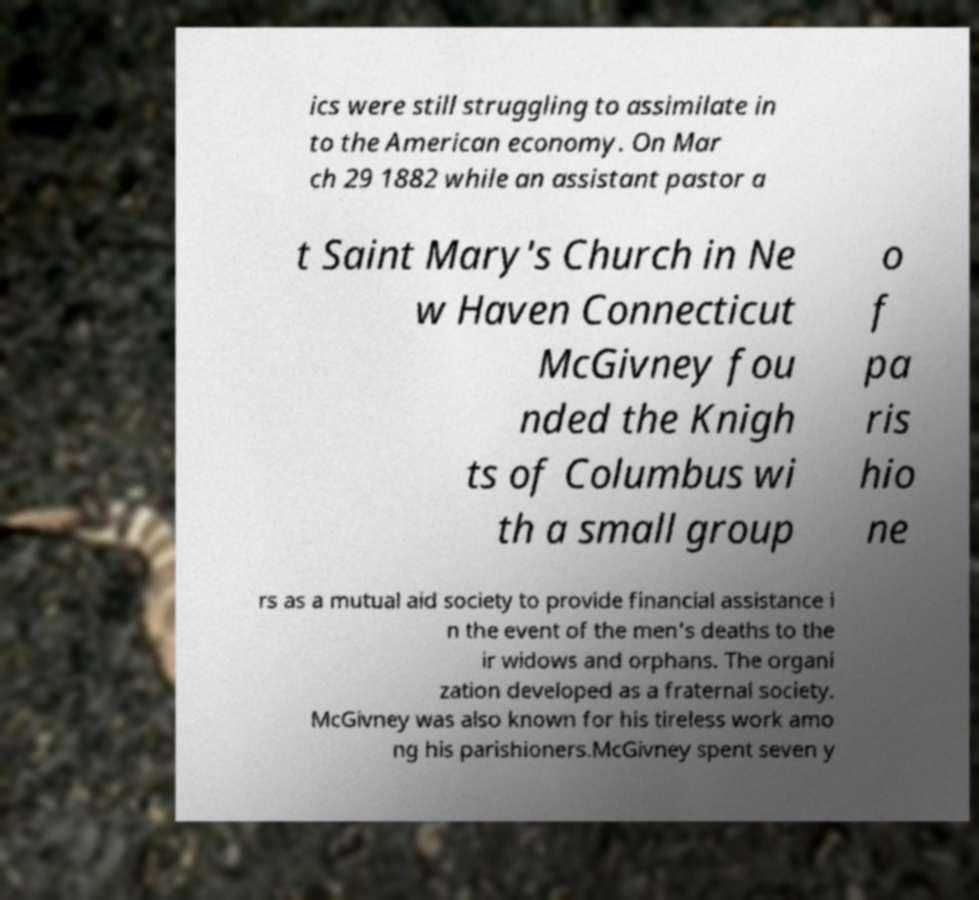There's text embedded in this image that I need extracted. Can you transcribe it verbatim? ics were still struggling to assimilate in to the American economy. On Mar ch 29 1882 while an assistant pastor a t Saint Mary's Church in Ne w Haven Connecticut McGivney fou nded the Knigh ts of Columbus wi th a small group o f pa ris hio ne rs as a mutual aid society to provide financial assistance i n the event of the men's deaths to the ir widows and orphans. The organi zation developed as a fraternal society. McGivney was also known for his tireless work amo ng his parishioners.McGivney spent seven y 